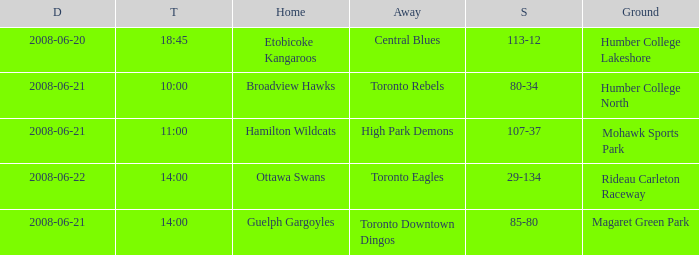What is the Ground with a Date that is 2008-06-20? Humber College Lakeshore. 